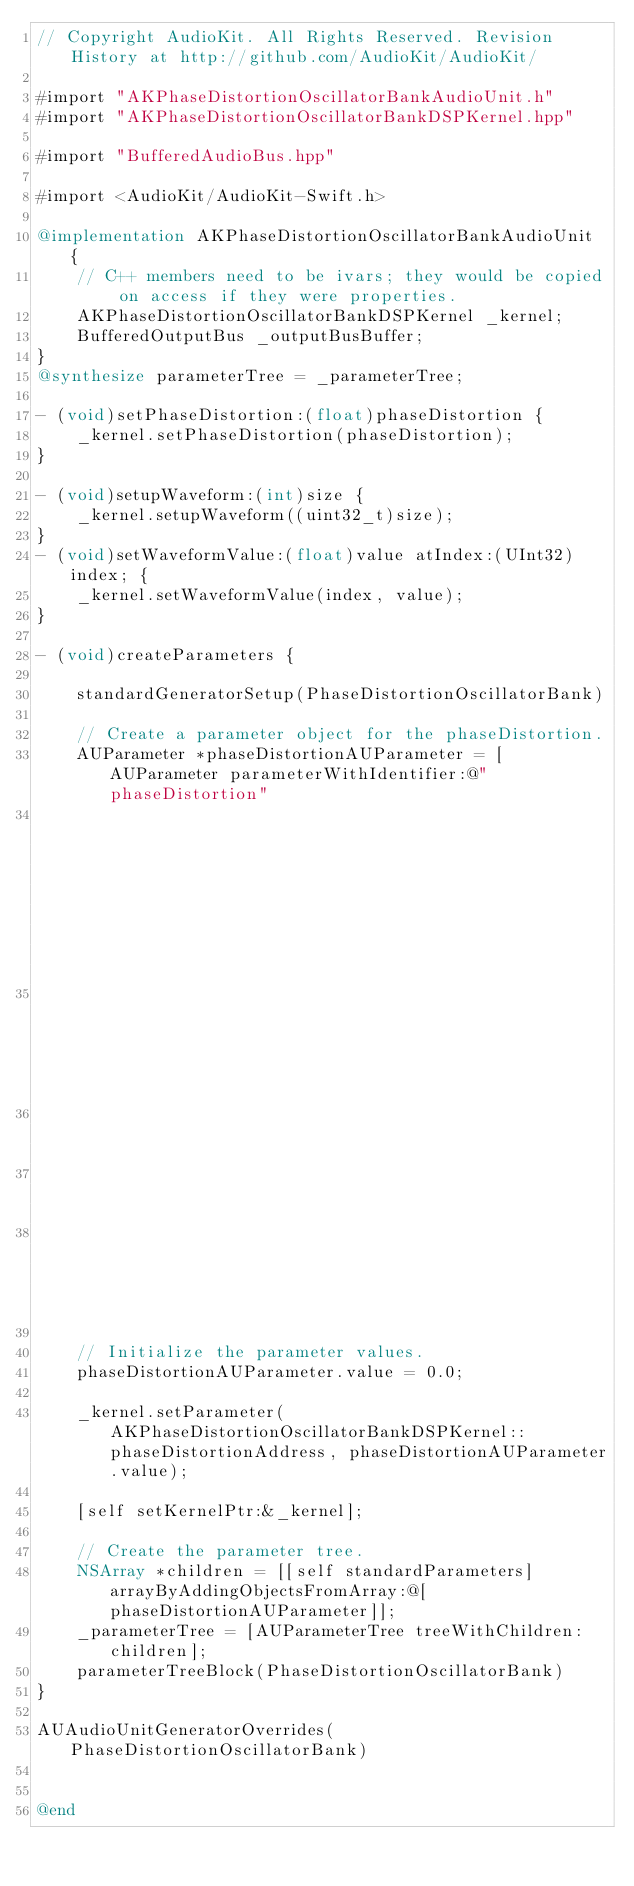<code> <loc_0><loc_0><loc_500><loc_500><_ObjectiveC_>// Copyright AudioKit. All Rights Reserved. Revision History at http://github.com/AudioKit/AudioKit/

#import "AKPhaseDistortionOscillatorBankAudioUnit.h"
#import "AKPhaseDistortionOscillatorBankDSPKernel.hpp"

#import "BufferedAudioBus.hpp"

#import <AudioKit/AudioKit-Swift.h>

@implementation AKPhaseDistortionOscillatorBankAudioUnit {
    // C++ members need to be ivars; they would be copied on access if they were properties.
    AKPhaseDistortionOscillatorBankDSPKernel _kernel;
    BufferedOutputBus _outputBusBuffer;
}
@synthesize parameterTree = _parameterTree;

- (void)setPhaseDistortion:(float)phaseDistortion {
    _kernel.setPhaseDistortion(phaseDistortion);
}

- (void)setupWaveform:(int)size {
    _kernel.setupWaveform((uint32_t)size);
}
- (void)setWaveformValue:(float)value atIndex:(UInt32)index; {
    _kernel.setWaveformValue(index, value);
}

- (void)createParameters {
    
    standardGeneratorSetup(PhaseDistortionOscillatorBank)
    
    // Create a parameter object for the phaseDistortion.
    AUParameter *phaseDistortionAUParameter = [AUParameter parameterWithIdentifier:@"phaseDistortion"
                                                                              name:@"Phase Distortion"
                                                                           address:AKPhaseDistortionOscillatorBankDSPKernel::phaseDistortionAddress
                                                                               min:0.0
                                                                               max:1.0
                                                                              unit:kAudioUnitParameterUnit_Generic];
    
    // Initialize the parameter values.
    phaseDistortionAUParameter.value = 0.0;
    
    _kernel.setParameter(AKPhaseDistortionOscillatorBankDSPKernel::phaseDistortionAddress, phaseDistortionAUParameter.value);
    
    [self setKernelPtr:&_kernel];
    
    // Create the parameter tree.
    NSArray *children = [[self standardParameters] arrayByAddingObjectsFromArray:@[phaseDistortionAUParameter]];
    _parameterTree = [AUParameterTree treeWithChildren:children];
    parameterTreeBlock(PhaseDistortionOscillatorBank)
}

AUAudioUnitGeneratorOverrides(PhaseDistortionOscillatorBank)


@end


</code> 